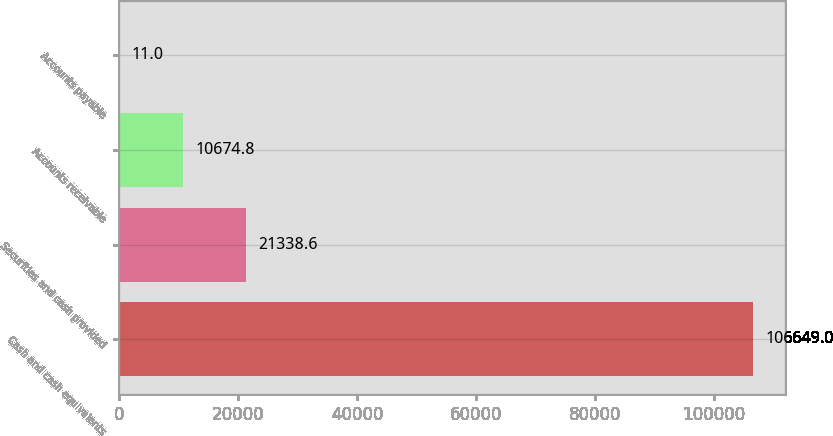Convert chart to OTSL. <chart><loc_0><loc_0><loc_500><loc_500><bar_chart><fcel>Cash and cash equivalents<fcel>Securities and cash provided<fcel>Accounts receivable<fcel>Accounts payable<nl><fcel>106649<fcel>21338.6<fcel>10674.8<fcel>11<nl></chart> 